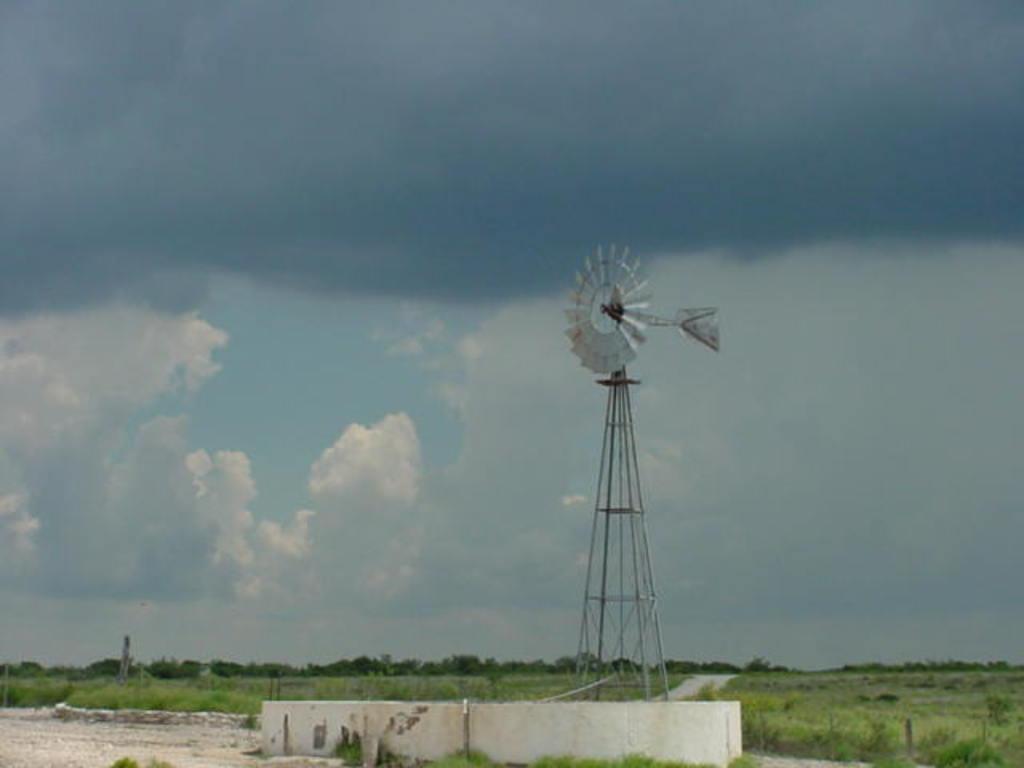Describe this image in one or two sentences. There is a wall at the bottom of this image and there are some trees in the background. There is a windmill in the middle of this image and behind to this windmill there is a sky. 